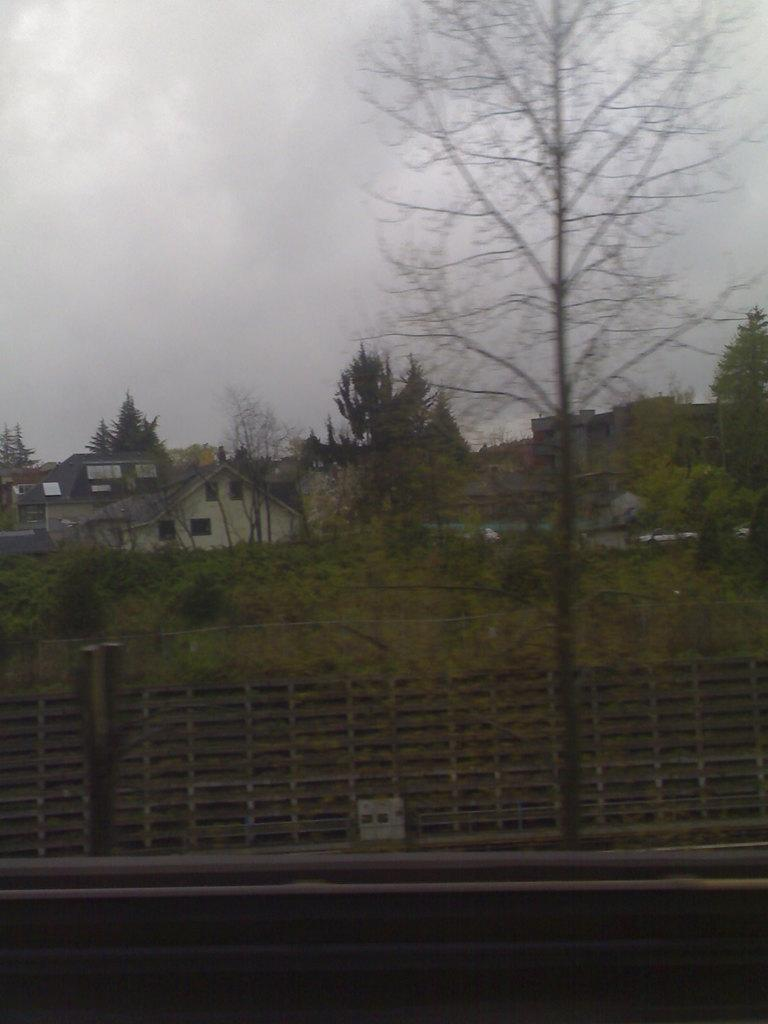What type of fencing is present in the image? There is a wooden fencing in the image. What can be seen behind the fencing? Trees and plants are visible behind the fencing. What structures are visible in the background of the image? There are houses in the background of the image. What type of minister is depicted on the train in the image? There is no minister or train present in the image. What is the size of the wooden fencing in the image? The size of the wooden fencing cannot be determined from the image alone, as there is no reference point for comparison. 